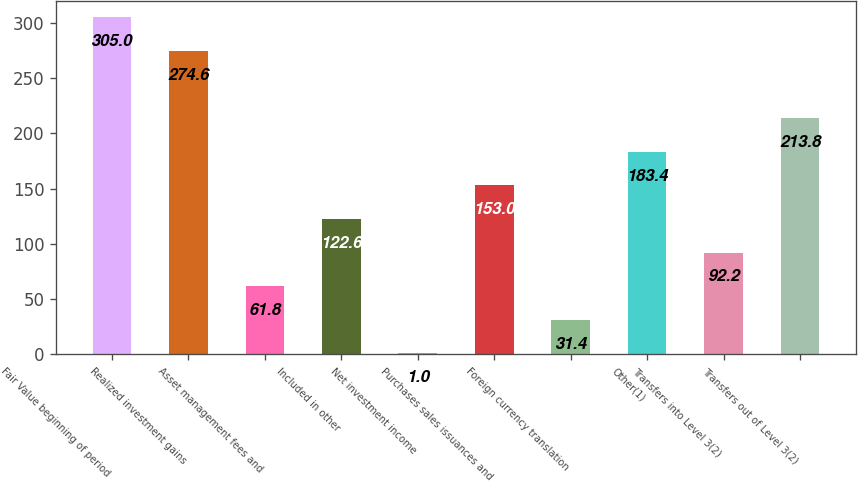<chart> <loc_0><loc_0><loc_500><loc_500><bar_chart><fcel>Fair Value beginning of period<fcel>Realized investment gains<fcel>Asset management fees and<fcel>Included in other<fcel>Net investment income<fcel>Purchases sales issuances and<fcel>Foreign currency translation<fcel>Other(1)<fcel>Transfers into Level 3(2)<fcel>Transfers out of Level 3(2)<nl><fcel>305<fcel>274.6<fcel>61.8<fcel>122.6<fcel>1<fcel>153<fcel>31.4<fcel>183.4<fcel>92.2<fcel>213.8<nl></chart> 